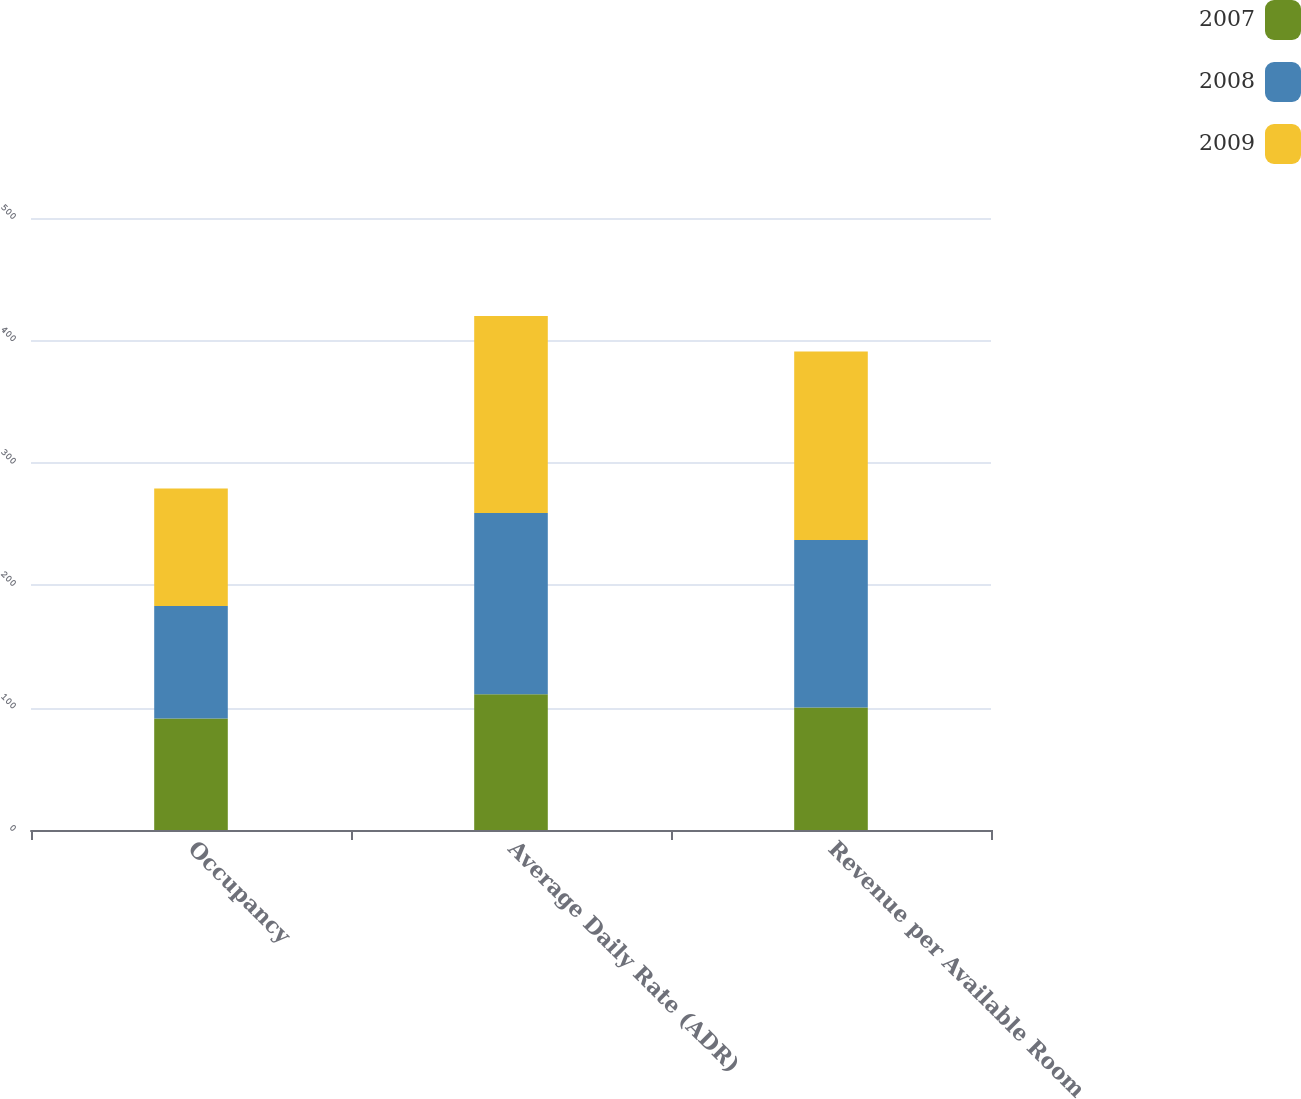Convert chart. <chart><loc_0><loc_0><loc_500><loc_500><stacked_bar_chart><ecel><fcel>Occupancy<fcel>Average Daily Rate (ADR)<fcel>Revenue per Available Room<nl><fcel>2007<fcel>91<fcel>111<fcel>100<nl><fcel>2008<fcel>92<fcel>148<fcel>137<nl><fcel>2009<fcel>96<fcel>161<fcel>154<nl></chart> 